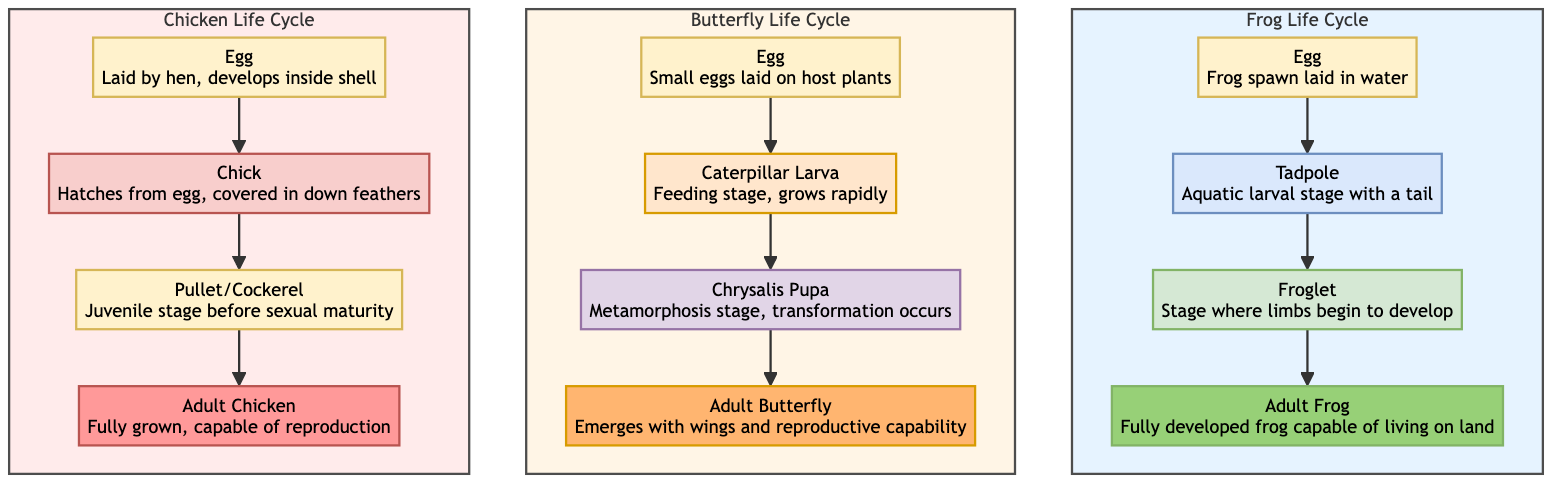What is the first stage of the Frog life cycle? The first stage of the Frog life cycle is "Egg". It can be found at the top of the Frog life cycle subgraph, where the progression begins.
Answer: Egg How many stages are there in the Butterfly life cycle? The Butterfly life cycle includes four stages: Egg, Caterpillar (Larva), Chrysalis (Pupa), and Adult Butterfly. By counting each listed stage, we see that there are a total of four stages.
Answer: 4 What stage comes after the Chick in the Chicken life cycle? The stage that comes after the Chick is "Pullet/Cockerel". This can be identified by following the arrows in the Chicken life cycle where "Chick" leads directly to "Pullet/Cockerel".
Answer: Pullet/Cockerel Which animal has a stage called "Froglet"? The "Froglet" stage is found in the Frog life cycle. This is determined by examining the stages within the Frog subgraph, where "Froglet" is clearly listed.
Answer: Frog What color represents the Chrysalis stage in the Butterfly life cycle? The Chrysalis stage is represented in a purple hue, as indicated by the specified class for that stage (chrysalisClass) within the diagram.
Answer: Purple How many total stages are represented across all three animals? Each animal has four stages—Frog (4), Butterfly (4), and Chicken (4)—resulting in a total of 12 stages when summed together: 4 + 4 + 4 = 12.
Answer: 12 Which animal has the last stage described as "Emerges with wings and reproductive capability"? The last stage described as "Emerges with wings and reproductive capability" is found in the Butterfly life cycle, directly listed as the final stage of that cycle.
Answer: Butterfly What is the transition from the Tadpole stage? The transition from the Tadpole stage goes to the Froglet stage, as indicated by the directional flow leading from "Tadpole" to "Froglet" in the Frog life cycle.
Answer: Froglet What stage follows the Egg in the Chicken life cycle? The stage that follows the Egg in the Chicken life cycle is "Chick". This is observed directly in the Chicken subgraph where "Egg" points to "Chick".
Answer: Chick 